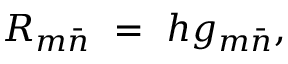Convert formula to latex. <formula><loc_0><loc_0><loc_500><loc_500>R _ { m { \bar { n } } } \ = \ h g _ { m { \bar { n } } } ,</formula> 